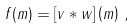Convert formula to latex. <formula><loc_0><loc_0><loc_500><loc_500>f ( m ) = \left [ v * w \right ] \left ( m \right ) \, ,</formula> 